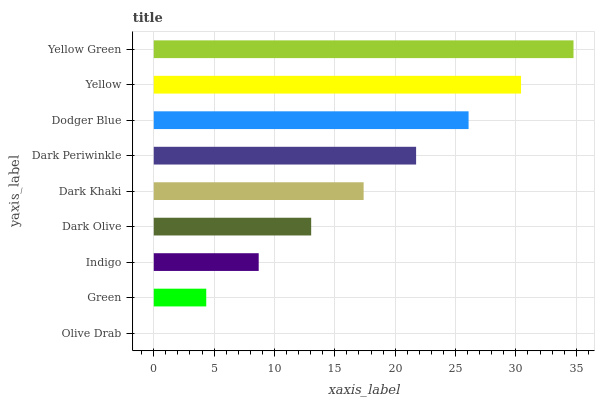Is Olive Drab the minimum?
Answer yes or no. Yes. Is Yellow Green the maximum?
Answer yes or no. Yes. Is Green the minimum?
Answer yes or no. No. Is Green the maximum?
Answer yes or no. No. Is Green greater than Olive Drab?
Answer yes or no. Yes. Is Olive Drab less than Green?
Answer yes or no. Yes. Is Olive Drab greater than Green?
Answer yes or no. No. Is Green less than Olive Drab?
Answer yes or no. No. Is Dark Khaki the high median?
Answer yes or no. Yes. Is Dark Khaki the low median?
Answer yes or no. Yes. Is Yellow the high median?
Answer yes or no. No. Is Dodger Blue the low median?
Answer yes or no. No. 